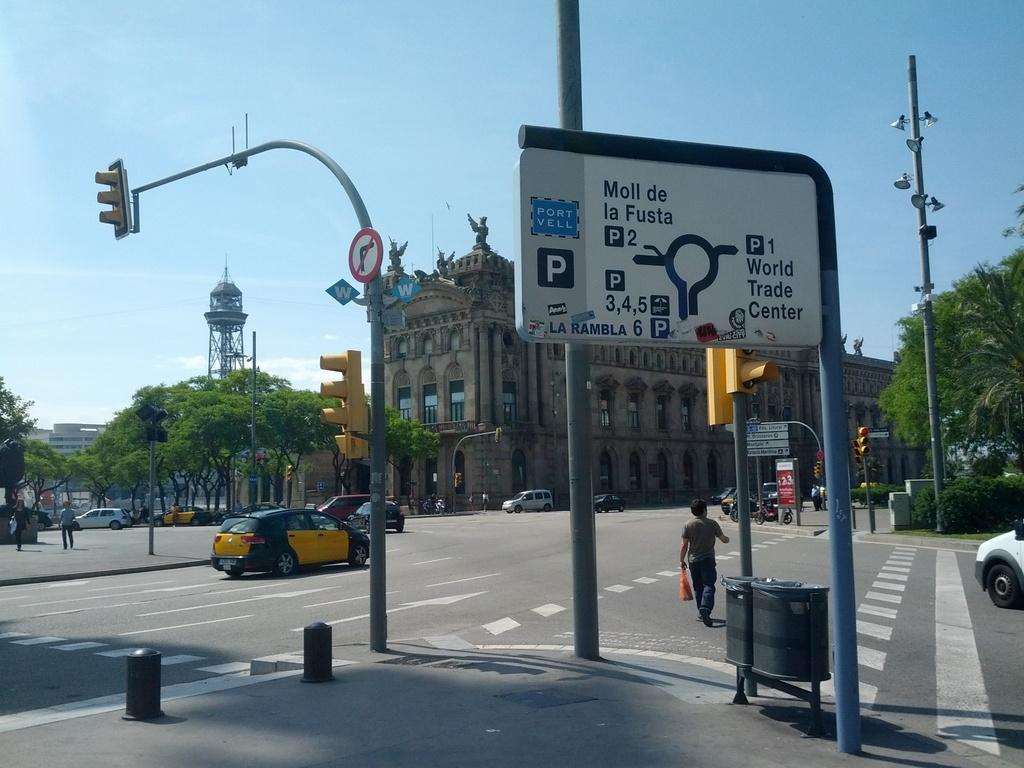<image>
Write a terse but informative summary of the picture. A Port Vell sign with a P on it is at a busy intersection. 